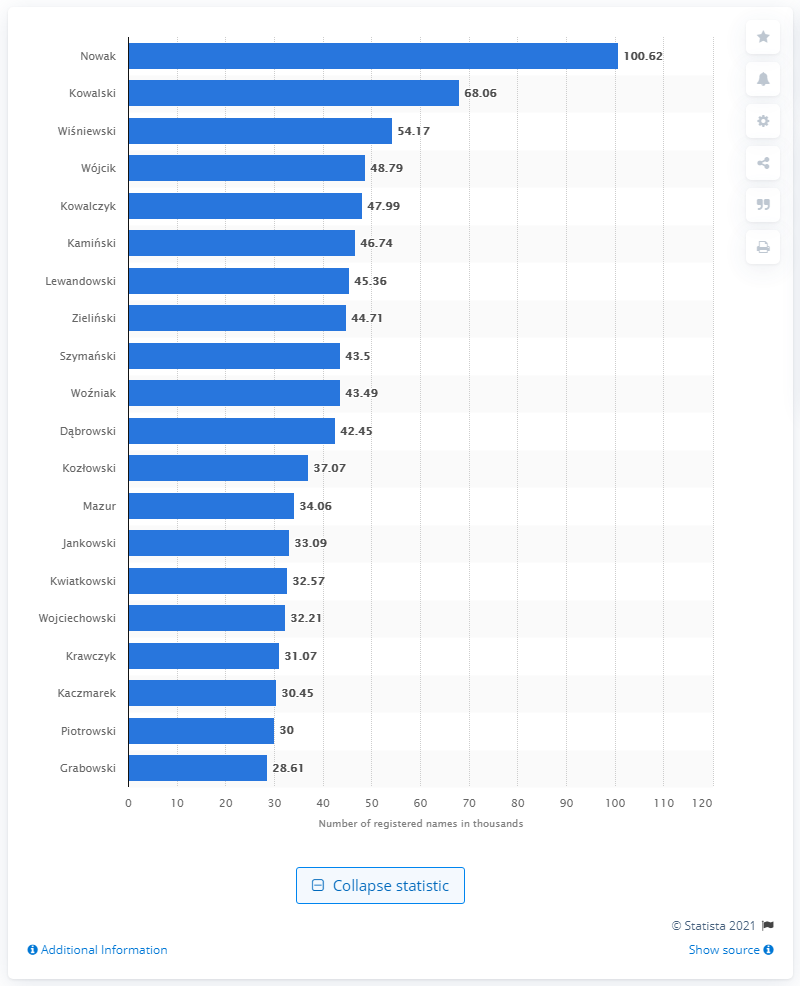Identify some key points in this picture. As of February 2021, the most popular male last name in Poland was Nowak. 